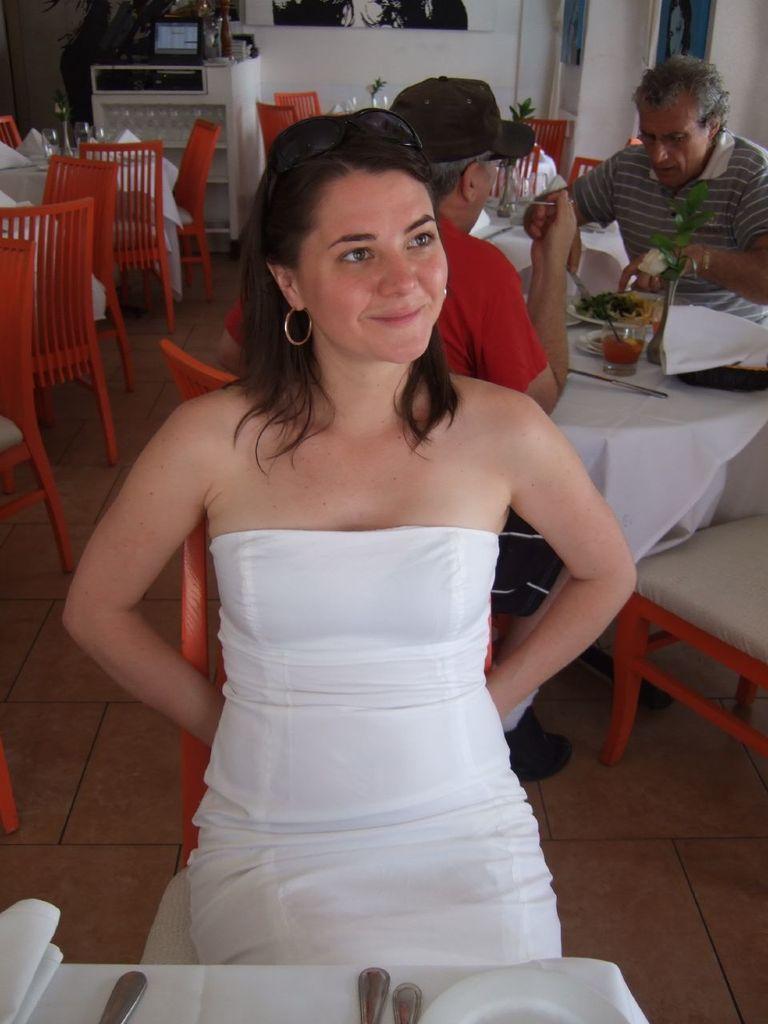In one or two sentences, can you explain what this image depicts? In this picture we can see woman smiling and sitting on chair and in front of her we can see table and on table we have spoons, plates,glasses, knife, cloth, some food and at back of her we can see two men sitting and in background we can see cupboard, wall with frames. 